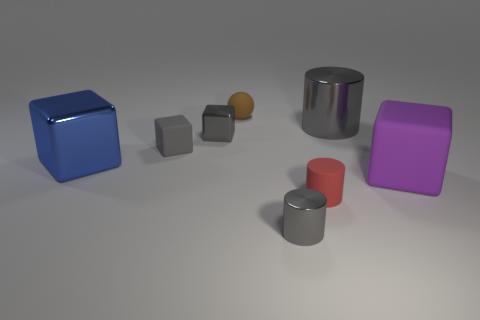There is a shiny cylinder that is the same size as the brown ball; what color is it?
Give a very brief answer. Gray. What number of other gray things have the same shape as the large rubber object?
Ensure brevity in your answer.  2. There is a blue metal object; is its size the same as the gray metal cylinder on the left side of the large cylinder?
Make the answer very short. No. There is a tiny metal thing that is left of the small gray shiny object in front of the red matte thing; what shape is it?
Make the answer very short. Cube. Is the number of blue cubes that are right of the small metallic cube less than the number of small purple metal blocks?
Provide a short and direct response. No. The tiny metal thing that is the same color as the small metallic cylinder is what shape?
Your answer should be compact. Cube. What number of gray metallic objects have the same size as the blue metallic thing?
Provide a succinct answer. 1. There is a object on the right side of the big gray metal cylinder; what shape is it?
Your answer should be compact. Cube. Is the number of small matte spheres less than the number of big red spheres?
Provide a succinct answer. No. Is there anything else of the same color as the big cylinder?
Offer a very short reply. Yes. 